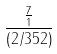Convert formula to latex. <formula><loc_0><loc_0><loc_500><loc_500>\frac { \frac { 7 } { 1 } } { ( 2 / 3 5 2 ) }</formula> 